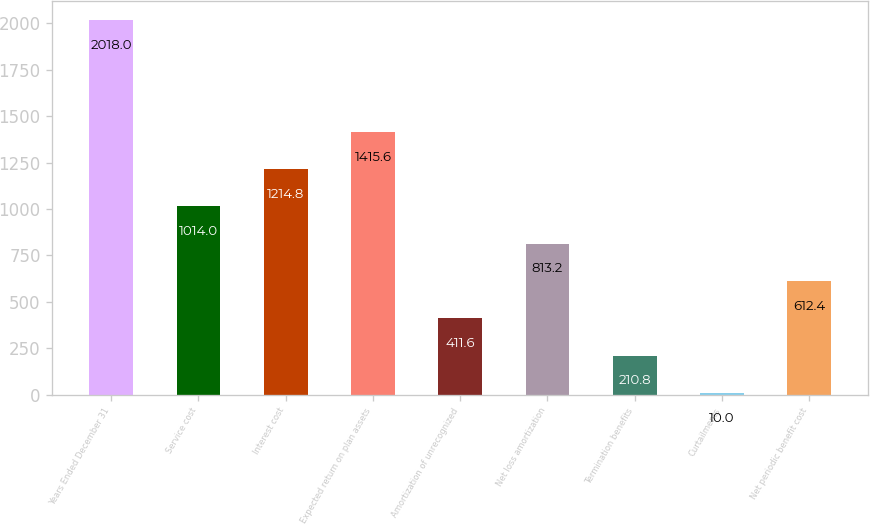Convert chart. <chart><loc_0><loc_0><loc_500><loc_500><bar_chart><fcel>Years Ended December 31<fcel>Service cost<fcel>Interest cost<fcel>Expected return on plan assets<fcel>Amortization of unrecognized<fcel>Net loss amortization<fcel>Termination benefits<fcel>Curtailments<fcel>Net periodic benefit cost<nl><fcel>2018<fcel>1014<fcel>1214.8<fcel>1415.6<fcel>411.6<fcel>813.2<fcel>210.8<fcel>10<fcel>612.4<nl></chart> 